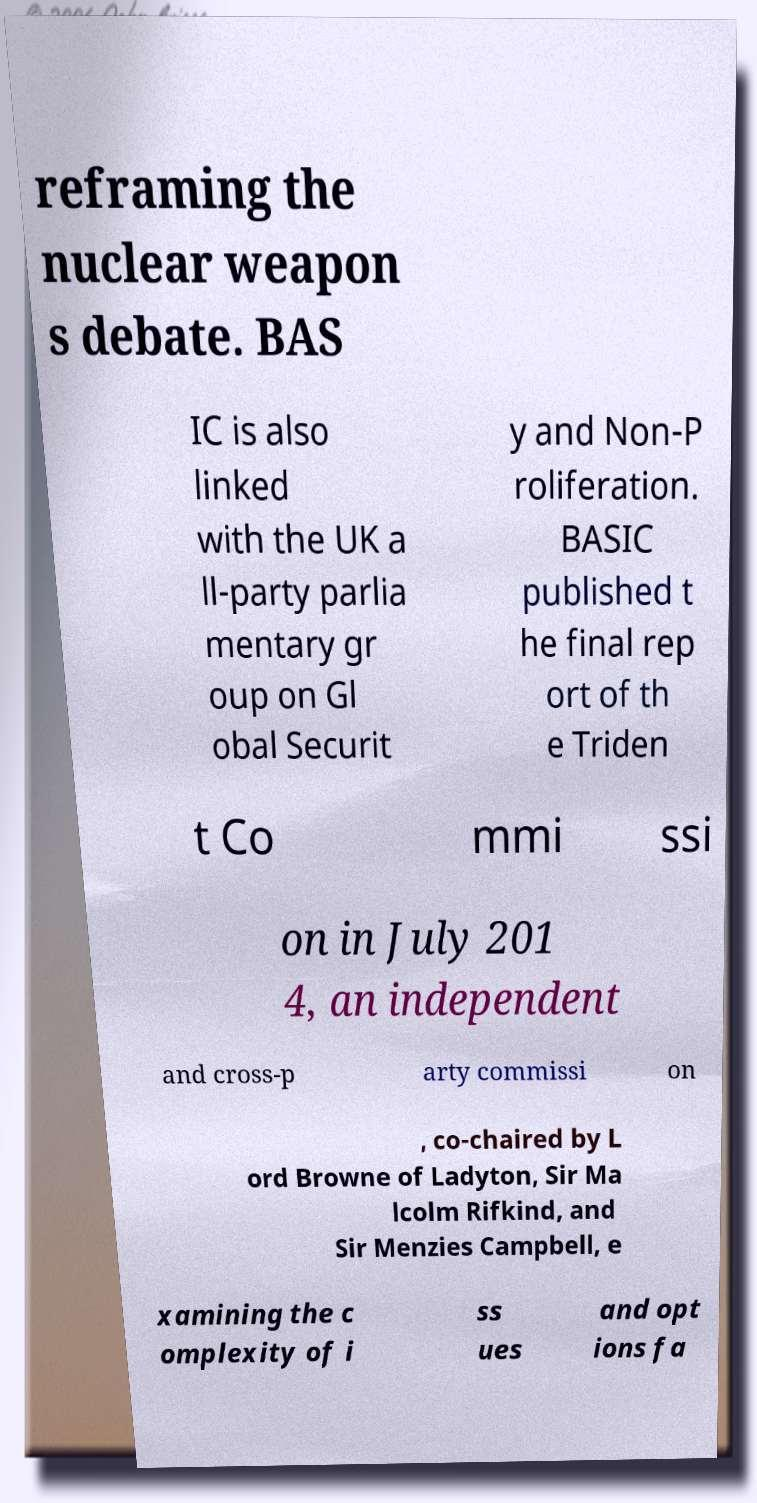Can you read and provide the text displayed in the image?This photo seems to have some interesting text. Can you extract and type it out for me? reframing the nuclear weapon s debate. BAS IC is also linked with the UK a ll-party parlia mentary gr oup on Gl obal Securit y and Non-P roliferation. BASIC published t he final rep ort of th e Triden t Co mmi ssi on in July 201 4, an independent and cross-p arty commissi on , co-chaired by L ord Browne of Ladyton, Sir Ma lcolm Rifkind, and Sir Menzies Campbell, e xamining the c omplexity of i ss ues and opt ions fa 